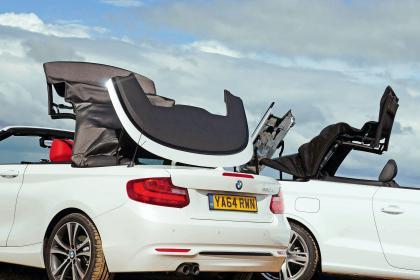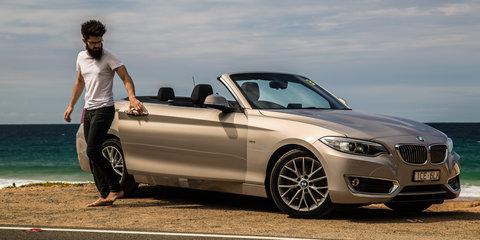The first image is the image on the left, the second image is the image on the right. For the images displayed, is the sentence "The right image contains two convertible vehicles." factually correct? Answer yes or no. No. The first image is the image on the left, the second image is the image on the right. Analyze the images presented: Is the assertion "One image features a cream-colored convertible and a taupe convertible, both topless and parked in front of water." valid? Answer yes or no. No. 